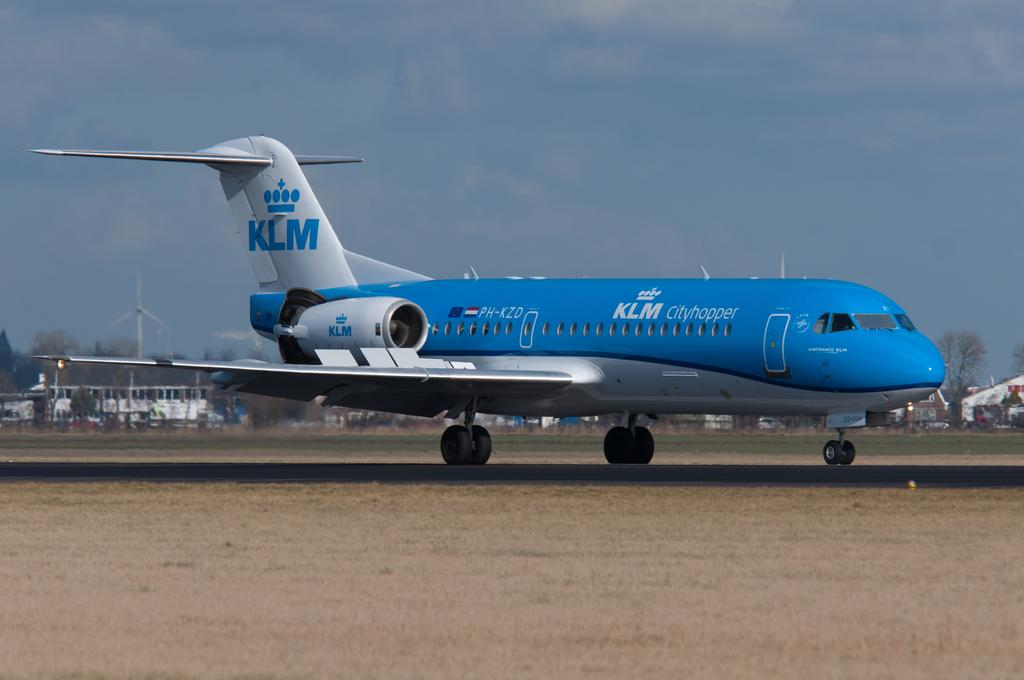<image>
Share a concise interpretation of the image provided. A blue and white KLM jet is on the ground. 